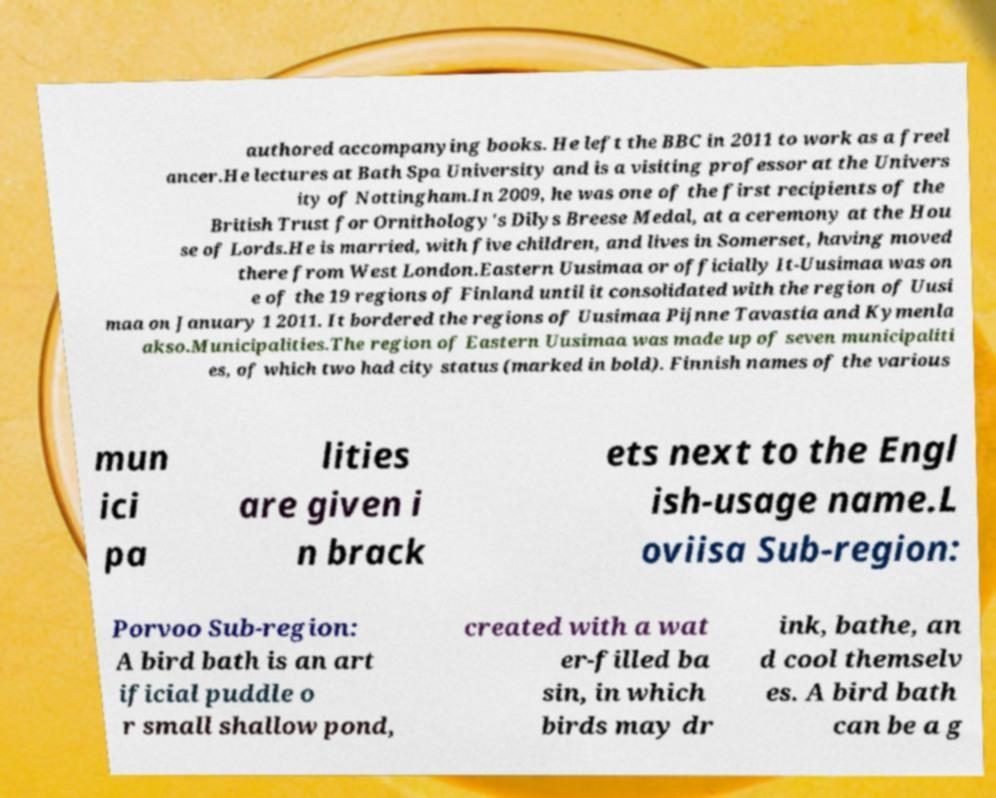Could you extract and type out the text from this image? authored accompanying books. He left the BBC in 2011 to work as a freel ancer.He lectures at Bath Spa University and is a visiting professor at the Univers ity of Nottingham.In 2009, he was one of the first recipients of the British Trust for Ornithology's Dilys Breese Medal, at a ceremony at the Hou se of Lords.He is married, with five children, and lives in Somerset, having moved there from West London.Eastern Uusimaa or officially It-Uusimaa was on e of the 19 regions of Finland until it consolidated with the region of Uusi maa on January 1 2011. It bordered the regions of Uusimaa Pijnne Tavastia and Kymenla akso.Municipalities.The region of Eastern Uusimaa was made up of seven municipaliti es, of which two had city status (marked in bold). Finnish names of the various mun ici pa lities are given i n brack ets next to the Engl ish-usage name.L oviisa Sub-region: Porvoo Sub-region: A bird bath is an art ificial puddle o r small shallow pond, created with a wat er-filled ba sin, in which birds may dr ink, bathe, an d cool themselv es. A bird bath can be a g 